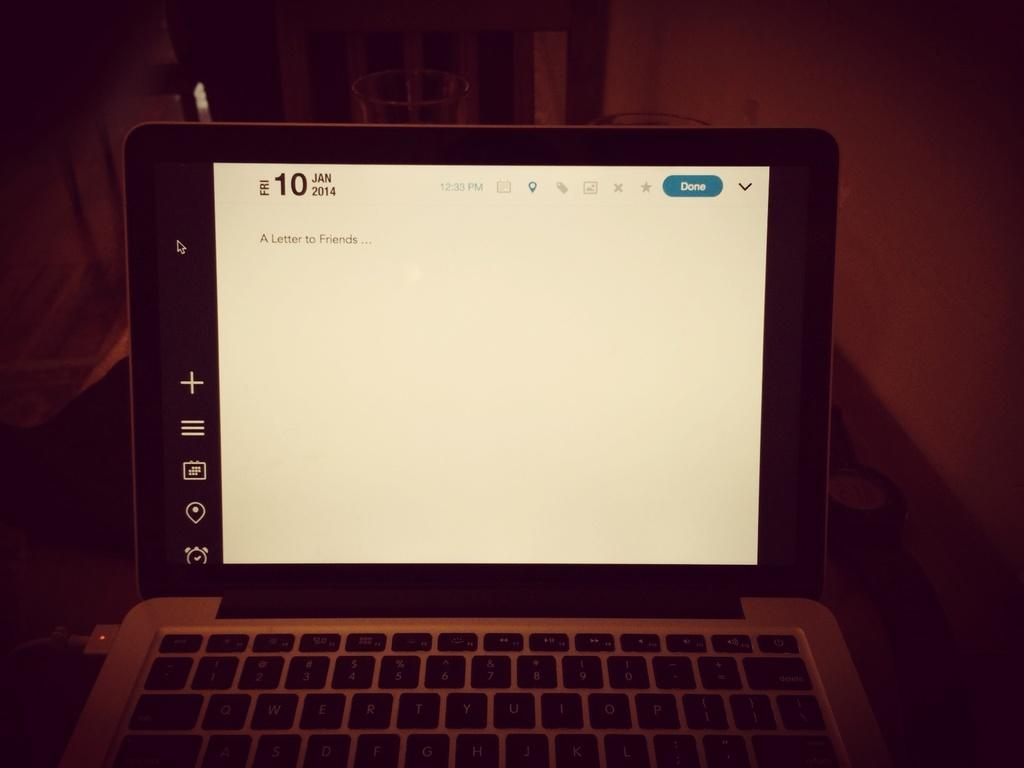<image>
Give a short and clear explanation of the subsequent image. the word done that is on the monitor 